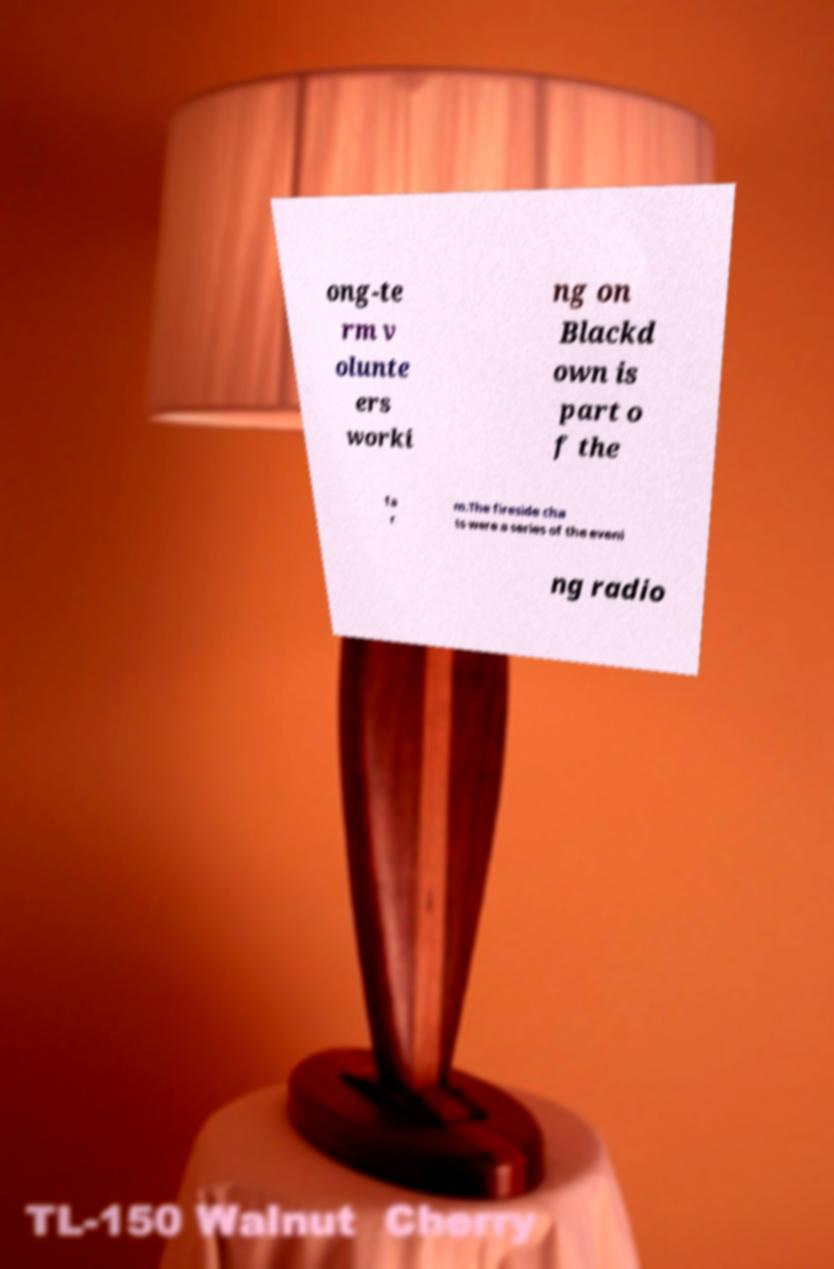I need the written content from this picture converted into text. Can you do that? ong-te rm v olunte ers worki ng on Blackd own is part o f the fa r m.The fireside cha ts were a series of the eveni ng radio 